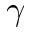<formula> <loc_0><loc_0><loc_500><loc_500>\gamma</formula> 